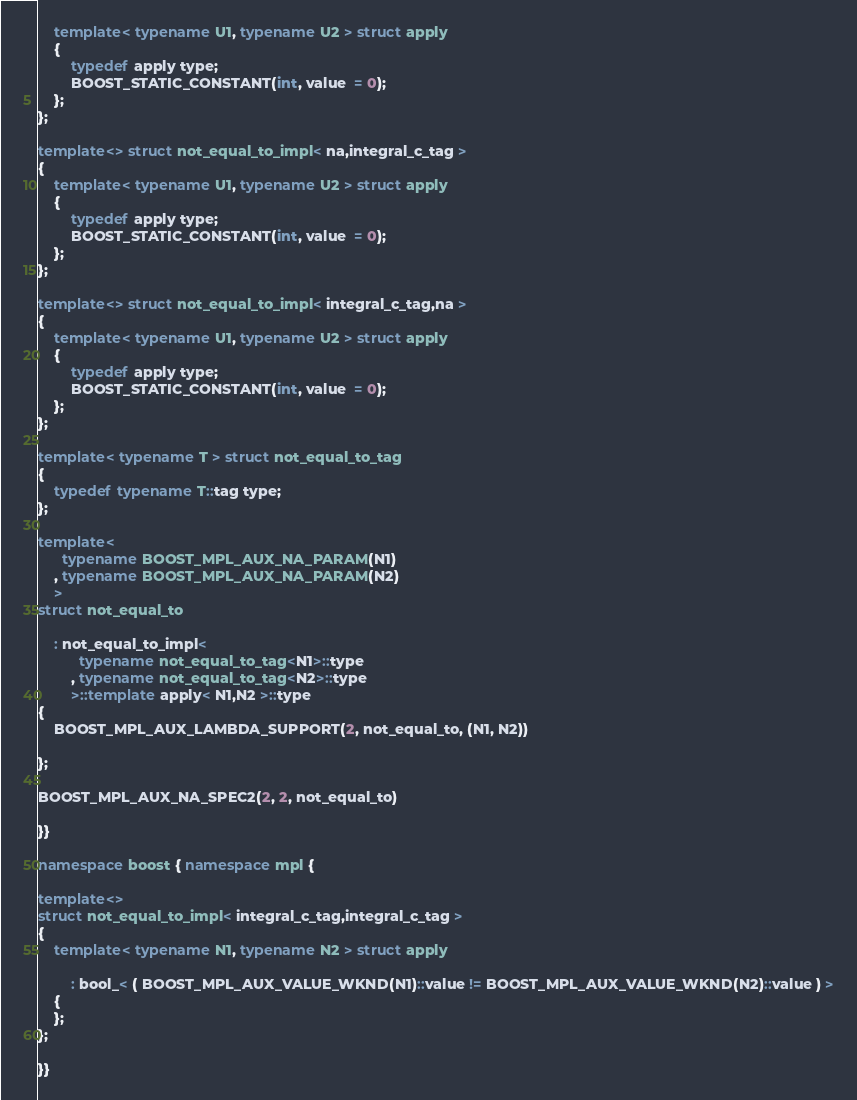<code> <loc_0><loc_0><loc_500><loc_500><_C++_>    template< typename U1, typename U2 > struct apply
    {
        typedef apply type;
        BOOST_STATIC_CONSTANT(int, value  = 0);
    };
};

template<> struct not_equal_to_impl< na,integral_c_tag >
{
    template< typename U1, typename U2 > struct apply
    {
        typedef apply type;
        BOOST_STATIC_CONSTANT(int, value  = 0);
    };
};

template<> struct not_equal_to_impl< integral_c_tag,na >
{
    template< typename U1, typename U2 > struct apply
    {
        typedef apply type;
        BOOST_STATIC_CONSTANT(int, value  = 0);
    };
};

template< typename T > struct not_equal_to_tag
{
    typedef typename T::tag type;
};

template<
      typename BOOST_MPL_AUX_NA_PARAM(N1)
    , typename BOOST_MPL_AUX_NA_PARAM(N2)
    >
struct not_equal_to

    : not_equal_to_impl<
          typename not_equal_to_tag<N1>::type
        , typename not_equal_to_tag<N2>::type
        >::template apply< N1,N2 >::type
{
    BOOST_MPL_AUX_LAMBDA_SUPPORT(2, not_equal_to, (N1, N2))

};

BOOST_MPL_AUX_NA_SPEC2(2, 2, not_equal_to)

}}

namespace boost { namespace mpl {

template<>
struct not_equal_to_impl< integral_c_tag,integral_c_tag >
{
    template< typename N1, typename N2 > struct apply

        : bool_< ( BOOST_MPL_AUX_VALUE_WKND(N1)::value != BOOST_MPL_AUX_VALUE_WKND(N2)::value ) >
    {
    };
};

}}
</code> 